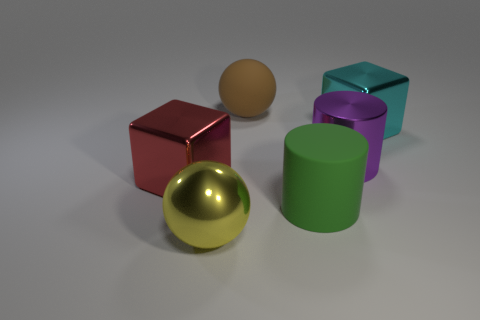Are there more green things that are in front of the rubber sphere than small purple objects?
Your response must be concise. Yes. What size is the brown rubber ball?
Your answer should be very brief. Large. How many things are either purple objects or things that are left of the cyan metallic object?
Provide a succinct answer. 5. How many metallic objects are to the right of the big red cube on the left side of the big metal block right of the big brown rubber ball?
Offer a very short reply. 3. What number of balls are there?
Offer a terse response. 2. There is a metallic block to the left of the cyan shiny cube; is its size the same as the yellow shiny thing?
Offer a terse response. Yes. What number of rubber objects are tiny purple blocks or brown objects?
Your answer should be compact. 1. There is a yellow shiny ball that is on the left side of the brown thing; how many large blocks are left of it?
Offer a terse response. 1. There is a big object that is both in front of the large purple cylinder and right of the metal ball; what is its shape?
Offer a very short reply. Cylinder. What material is the large object that is in front of the big matte thing in front of the block that is on the left side of the large yellow shiny object made of?
Offer a terse response. Metal. 